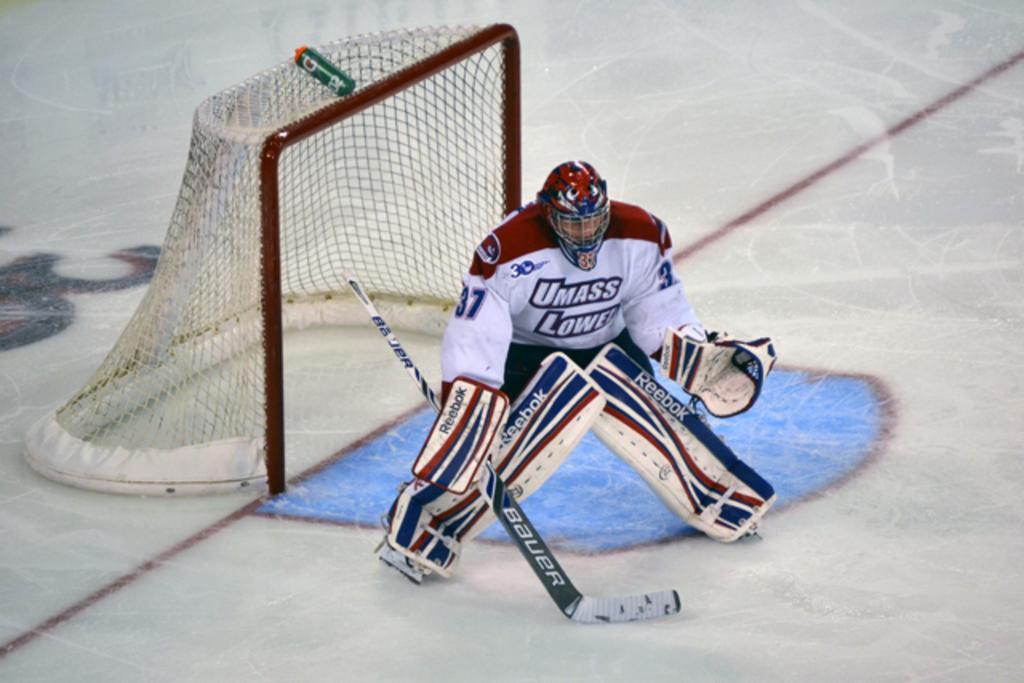In one or two sentences, can you explain what this image depicts? In the foreground of this image, there is a man standing, wearing gloves, knee pads and holding a hockey bat on the ice surface. Behind him, there is a goal net. 